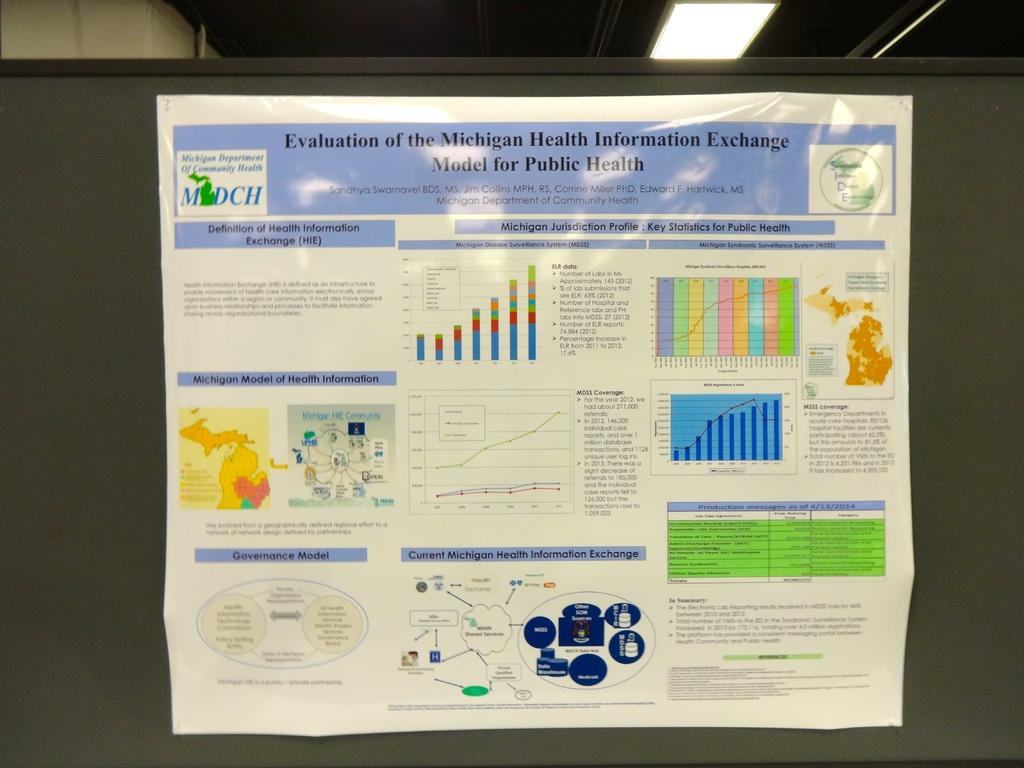This health information exchange on the picture is based in which state of america?
Ensure brevity in your answer.  Michigan. 